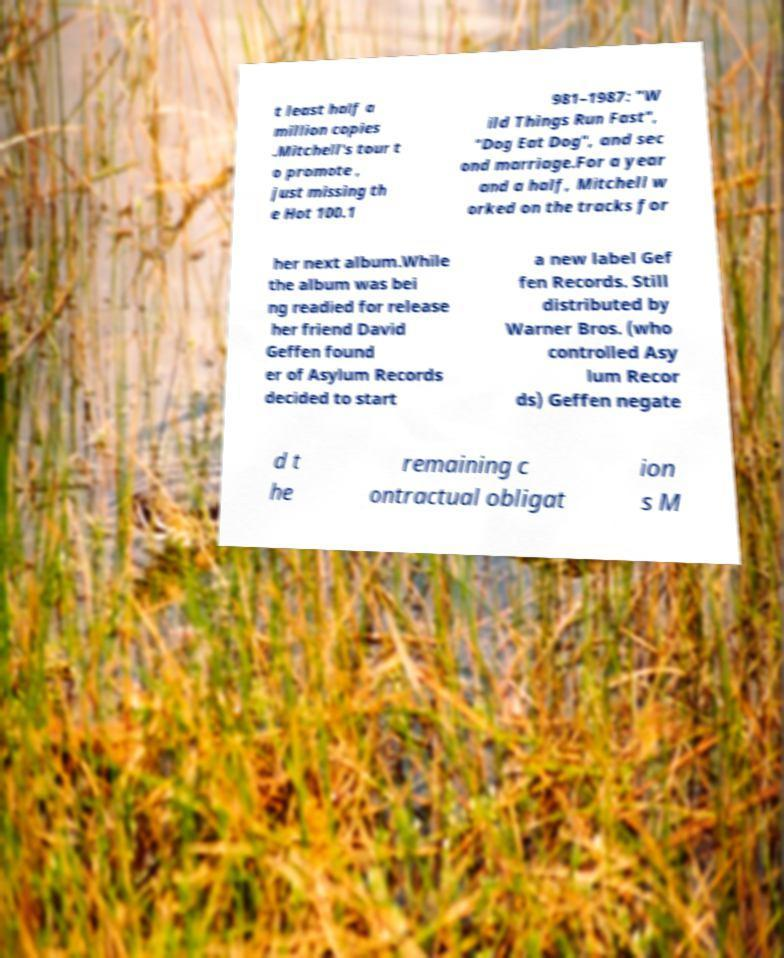I need the written content from this picture converted into text. Can you do that? t least half a million copies .Mitchell's tour t o promote , just missing th e Hot 100.1 981–1987: "W ild Things Run Fast", "Dog Eat Dog", and sec ond marriage.For a year and a half, Mitchell w orked on the tracks for her next album.While the album was bei ng readied for release her friend David Geffen found er of Asylum Records decided to start a new label Gef fen Records. Still distributed by Warner Bros. (who controlled Asy lum Recor ds) Geffen negate d t he remaining c ontractual obligat ion s M 